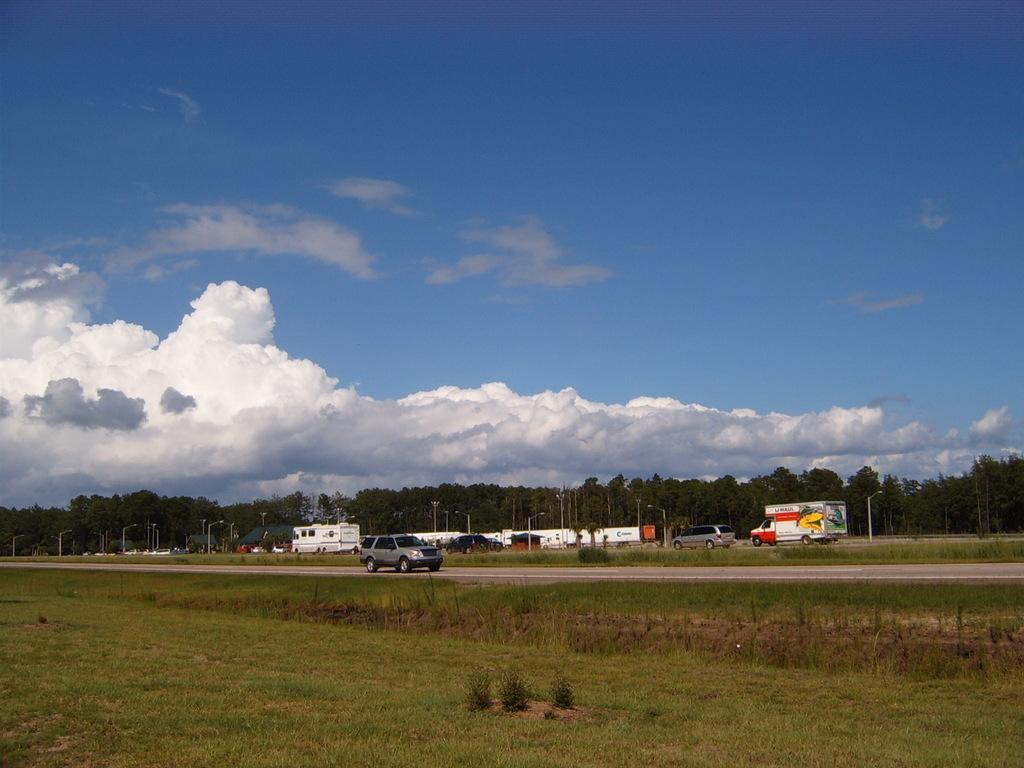Can you describe this image briefly? This picture shows grass on the ground and we see a blue cloudy sky and we see trees and few vehicles parked and we see few pole lights and we see a car moving on the road. 